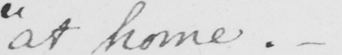Transcribe the text shown in this historical manuscript line. " at home . "  _ 